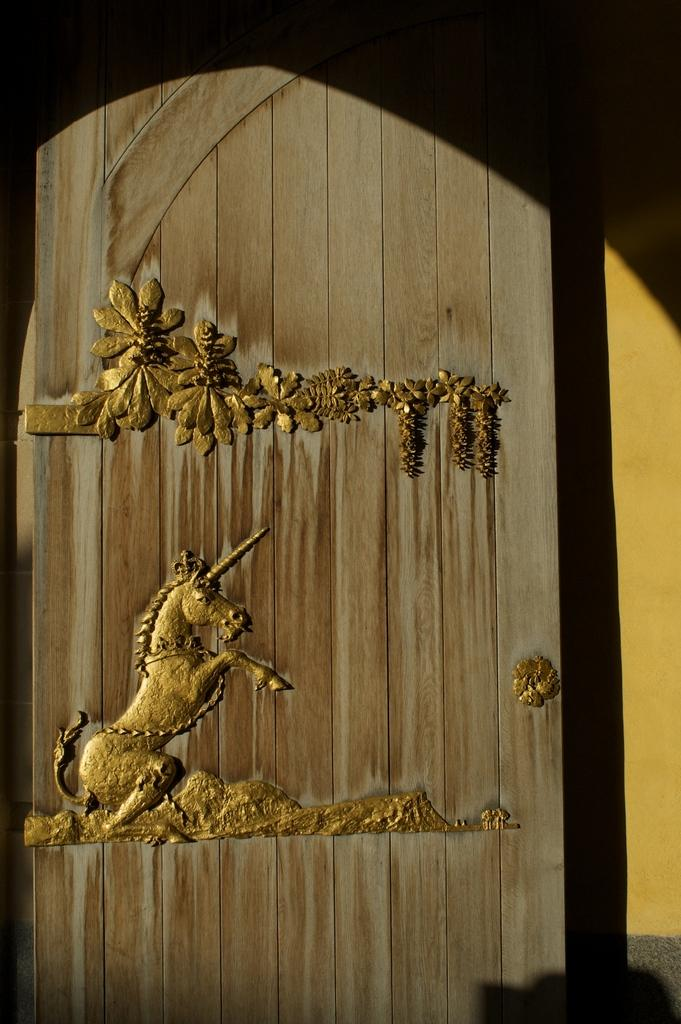What is depicted in the art in the image? There is an art of a horse in the image. What can be seen on the door in the image? There are plants on the door in the image. How many volleyballs are hanging from the plants on the door in the image? There are no volleyballs present in the image; it only features an art of a horse and plants on the door. 